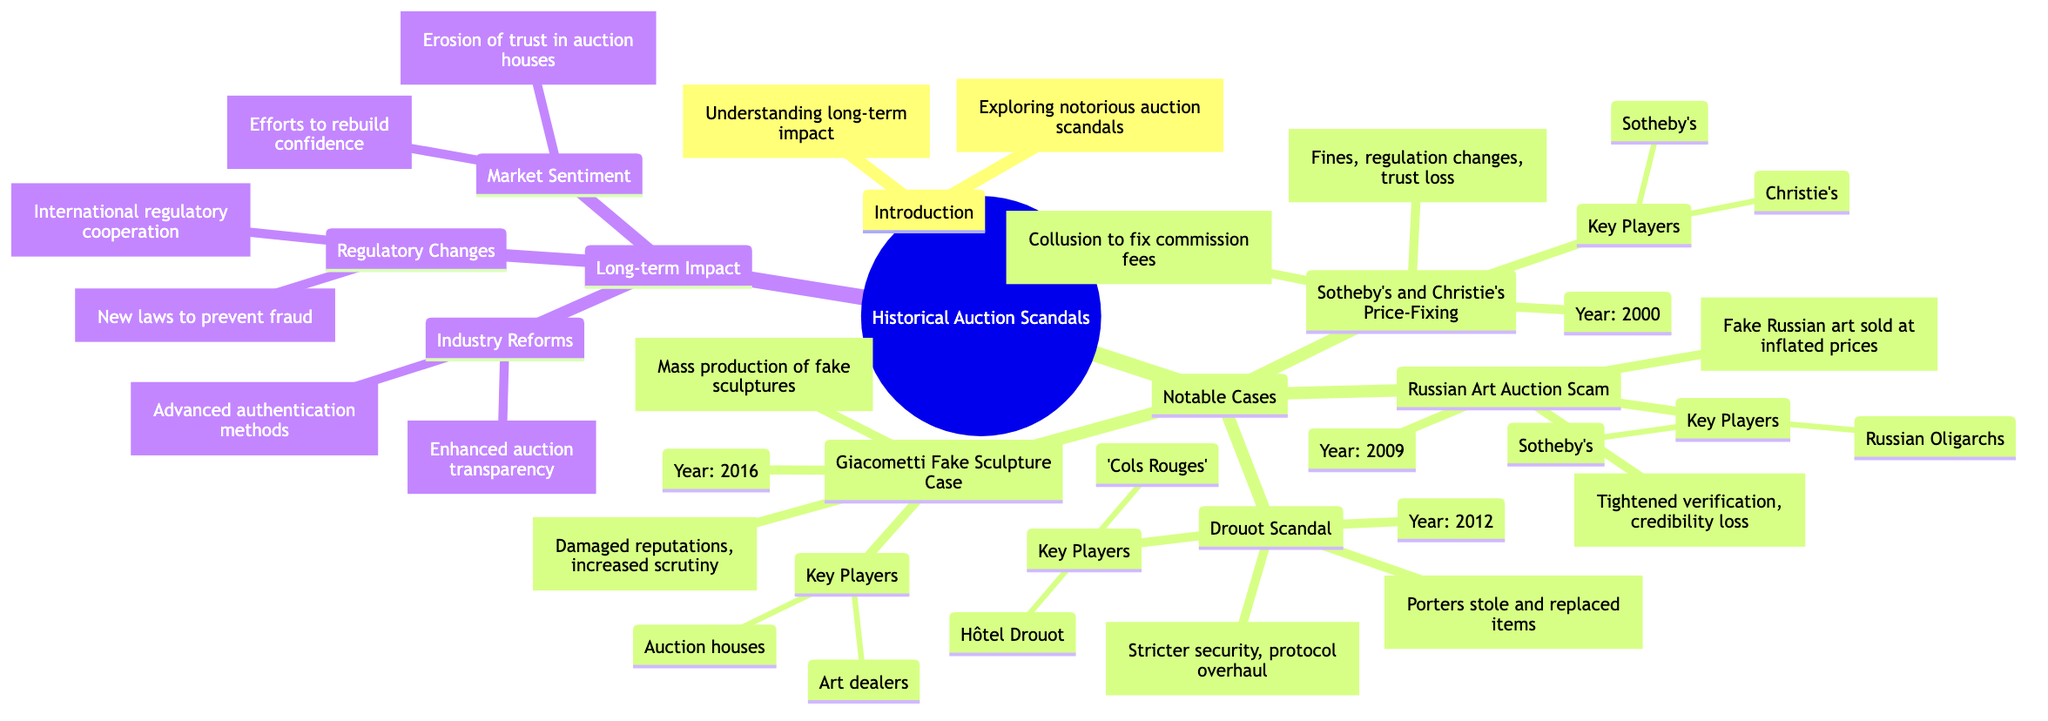What is the year of the Sotheby's and Christie's Price-Fixing Scandal? By locating the node for "Sotheby's and Christie's Price-Fixing Scandal," I can see that the year mentioned is 2000.
Answer: 2000 Who were the key players in the Drouot Scandal? The node for "Drouot Scandal" lists "Hôtel Drouot" and "The 'Cols Rouges'" under the key players section.
Answer: Hôtel Drouot, The 'Cols Rouges' What was one impact of the Giacometti Fake Sculpture Case? Referencing the "Giacometti Fake Sculpture Case" node, one stated impact is "Damaged reputations."
Answer: Damaged reputations What type of measures were introduced after the Russian Art Auction Scam? By reviewing the "Long-term Impact" and its subsections, it specifies "Tightened verification processes" as a response to the scam.
Answer: Tightened verification processes How many notable cases are listed in the diagram? The "Notable Cases" section includes four cases, counting them: Sotheby's and Christie's Price-Fixing, Russian Art Auction Scam, Drouot Scandal, and Giacometti Fake Sculpture Case.
Answer: 4 What major change occurred in regulatory practices after the auction scandals? The "Regulatory Changes" section indicates "Stricter Regulations" as a new measure implemented to address fraud.
Answer: Stricter Regulations Which scandal occurred in 2016? The node marked with the year 2016 refers to the "Giacometti Fake Sculpture Case."
Answer: Giacometti Fake Sculpture Case What is one of the industry reforms mentioned in the diagram? Under "Industry Reforms," the diagram states "Enhanced transparency" as one of the reforms.
Answer: Enhanced transparency 